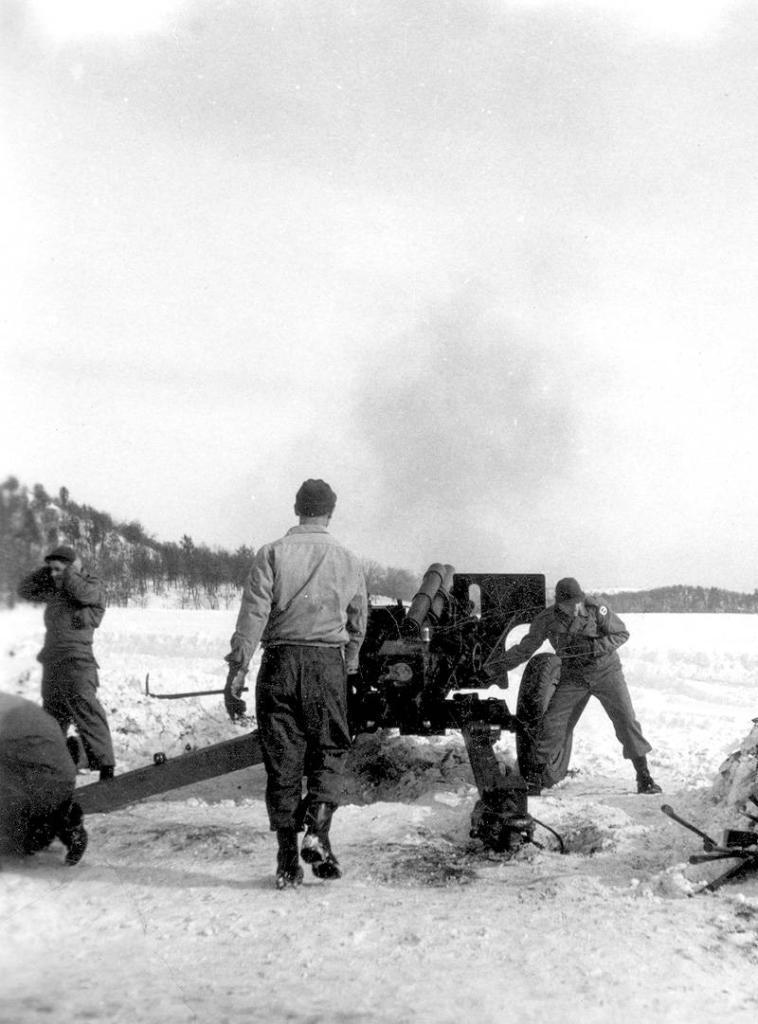In one or two sentences, can you explain what this image depicts? In this image we can see there are so many people standing beside the missile and operating it, beside them there are so many trees on the mountain. 